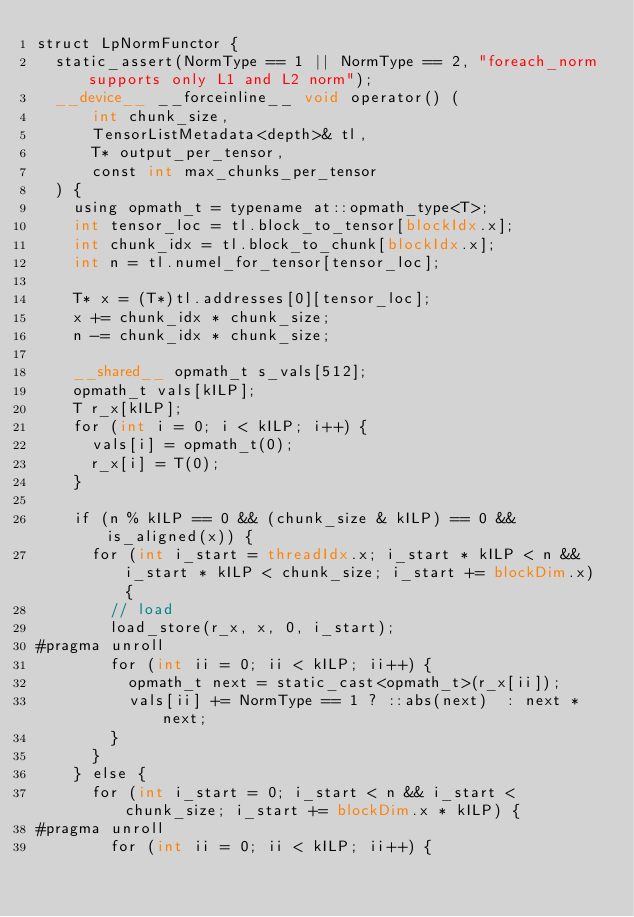<code> <loc_0><loc_0><loc_500><loc_500><_Cuda_>struct LpNormFunctor {
  static_assert(NormType == 1 || NormType == 2, "foreach_norm supports only L1 and L2 norm");
  __device__ __forceinline__ void operator() (
      int chunk_size,
      TensorListMetadata<depth>& tl,
      T* output_per_tensor,
      const int max_chunks_per_tensor
  ) {
    using opmath_t = typename at::opmath_type<T>;
    int tensor_loc = tl.block_to_tensor[blockIdx.x];
    int chunk_idx = tl.block_to_chunk[blockIdx.x];
    int n = tl.numel_for_tensor[tensor_loc];

    T* x = (T*)tl.addresses[0][tensor_loc];
    x += chunk_idx * chunk_size;
    n -= chunk_idx * chunk_size;

    __shared__ opmath_t s_vals[512];
    opmath_t vals[kILP];
    T r_x[kILP];
    for (int i = 0; i < kILP; i++) {
      vals[i] = opmath_t(0);
      r_x[i] = T(0);
    }

    if (n % kILP == 0 && (chunk_size & kILP) == 0 && is_aligned(x)) {
      for (int i_start = threadIdx.x; i_start * kILP < n && i_start * kILP < chunk_size; i_start += blockDim.x) {
        // load
        load_store(r_x, x, 0, i_start);
#pragma unroll
        for (int ii = 0; ii < kILP; ii++) {
          opmath_t next = static_cast<opmath_t>(r_x[ii]);
          vals[ii] += NormType == 1 ? ::abs(next)  : next * next;
        }
      }
    } else {
      for (int i_start = 0; i_start < n && i_start < chunk_size; i_start += blockDim.x * kILP) {
#pragma unroll
        for (int ii = 0; ii < kILP; ii++) {</code> 